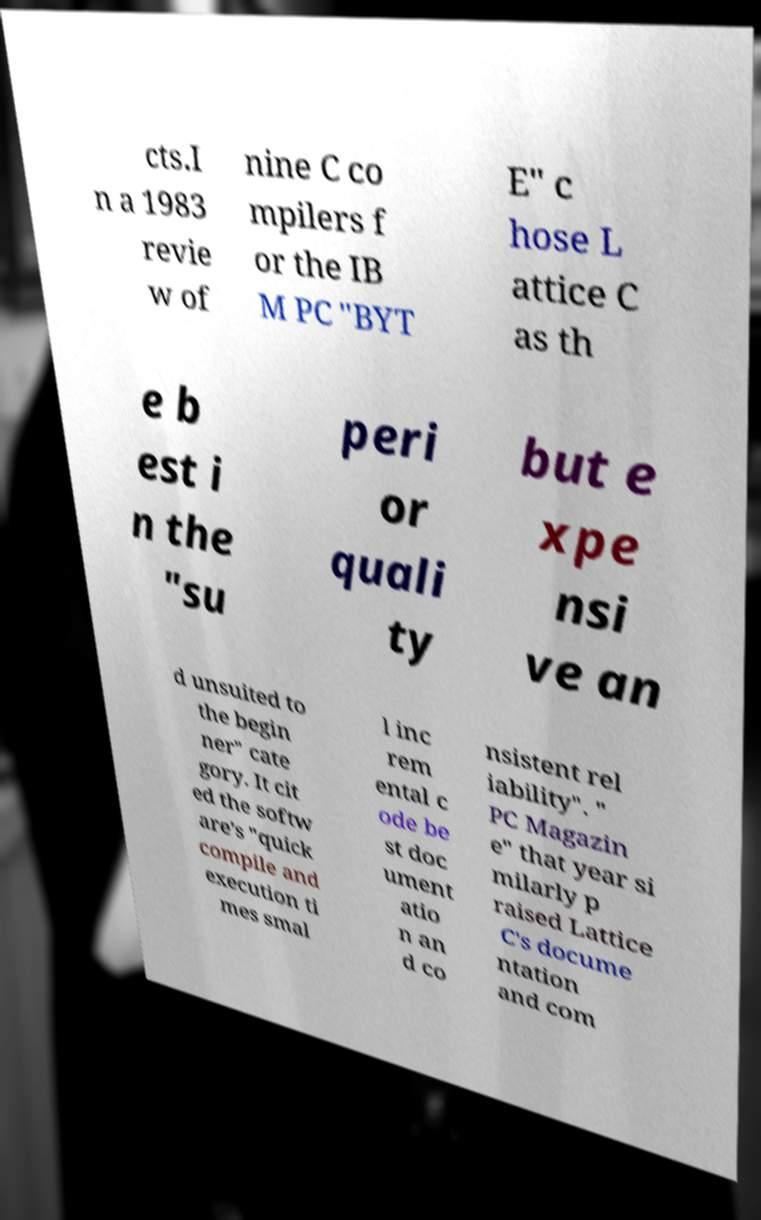For documentation purposes, I need the text within this image transcribed. Could you provide that? cts.I n a 1983 revie w of nine C co mpilers f or the IB M PC "BYT E" c hose L attice C as th e b est i n the "su peri or quali ty but e xpe nsi ve an d unsuited to the begin ner" cate gory. It cit ed the softw are's "quick compile and execution ti mes smal l inc rem ental c ode be st doc ument atio n an d co nsistent rel iability". " PC Magazin e" that year si milarly p raised Lattice C's docume ntation and com 